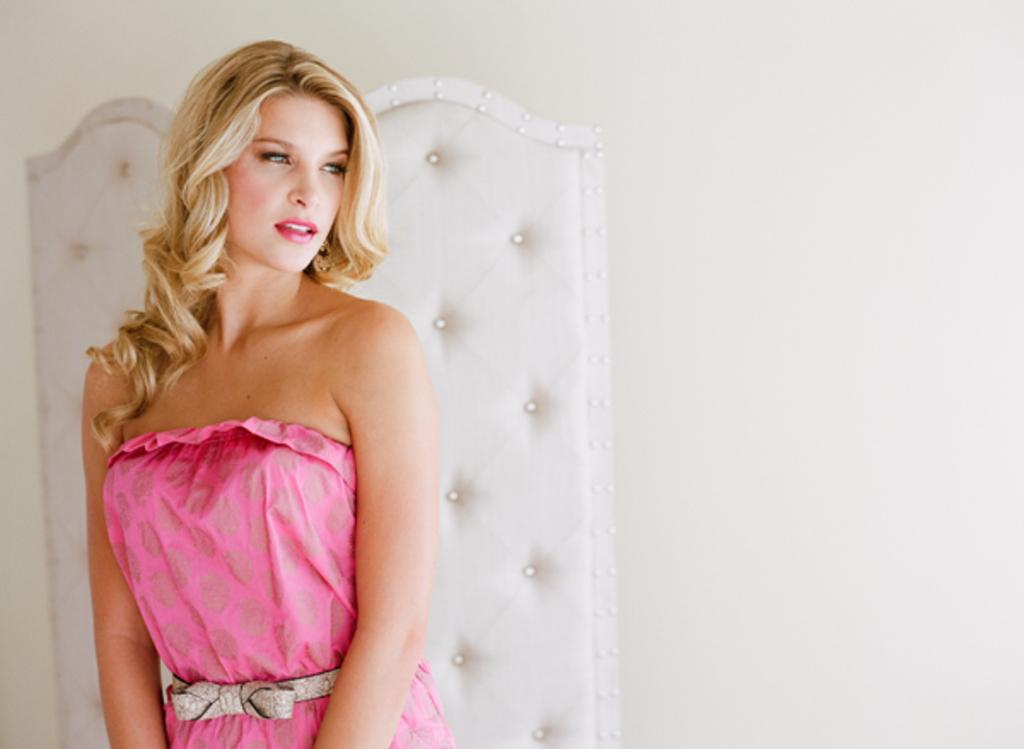What is the main subject of the image? The main subject of the image is a woman. What is the woman wearing in the image? The woman is wearing a pink dress. What expression does the woman have in the image? The woman is smiling in the image. Where is the woman located in the image? The woman is standing near a white wall in the image. What color is the object visible in the image? The object visible in the image is white. Can you tell me how many parents are visible in the image? There are no parents visible in the image; it features a woman standing near a white wall. What type of wax can be seen melting in the image? There is no wax present in the image. 